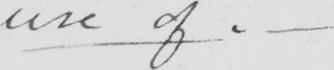Please provide the text content of this handwritten line. use of . _ 